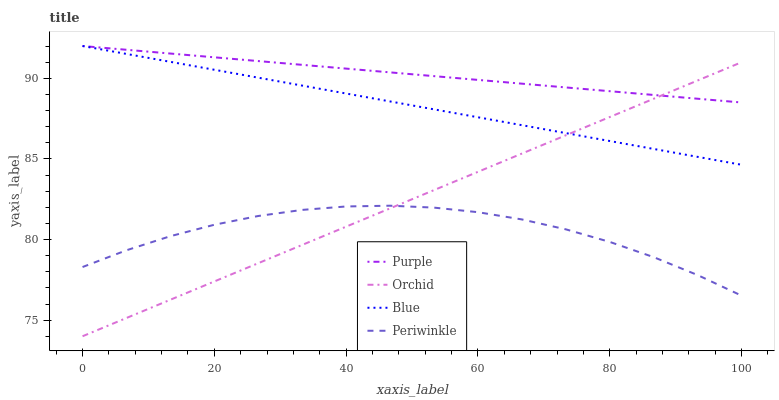Does Blue have the minimum area under the curve?
Answer yes or no. No. Does Blue have the maximum area under the curve?
Answer yes or no. No. Is Periwinkle the smoothest?
Answer yes or no. No. Is Blue the roughest?
Answer yes or no. No. Does Blue have the lowest value?
Answer yes or no. No. Does Periwinkle have the highest value?
Answer yes or no. No. Is Periwinkle less than Blue?
Answer yes or no. Yes. Is Purple greater than Periwinkle?
Answer yes or no. Yes. Does Periwinkle intersect Blue?
Answer yes or no. No. 